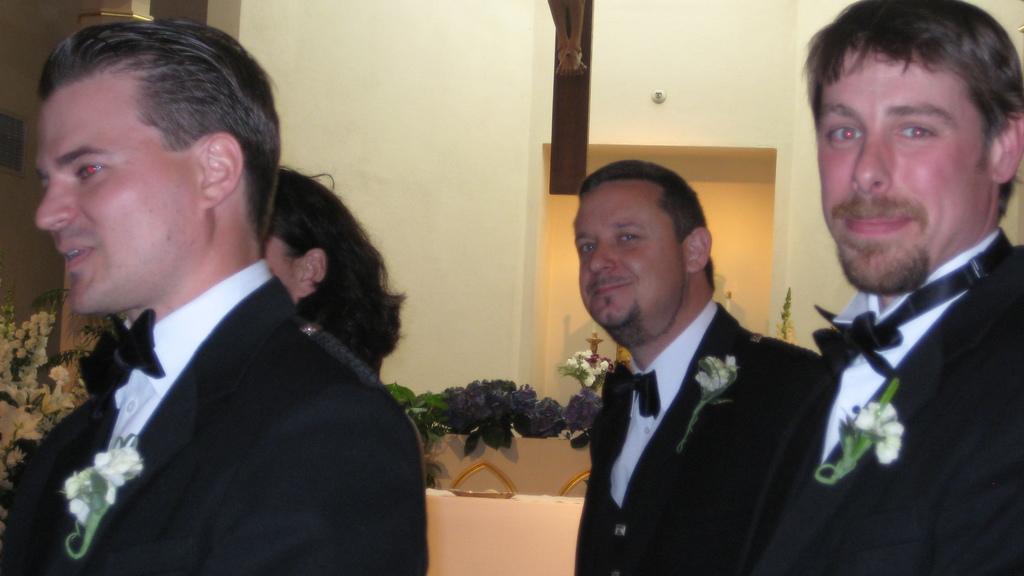Please provide a concise description of this image. In this picture, we see three men and a woman. They are smiling. Behind them, we see a table which is covered with white cloth. Behind that, we see a table on which plastic flowers are placed. Behind that, we see a wall and a flower vase. On the left side, we see a flower bouquet and a wall. 